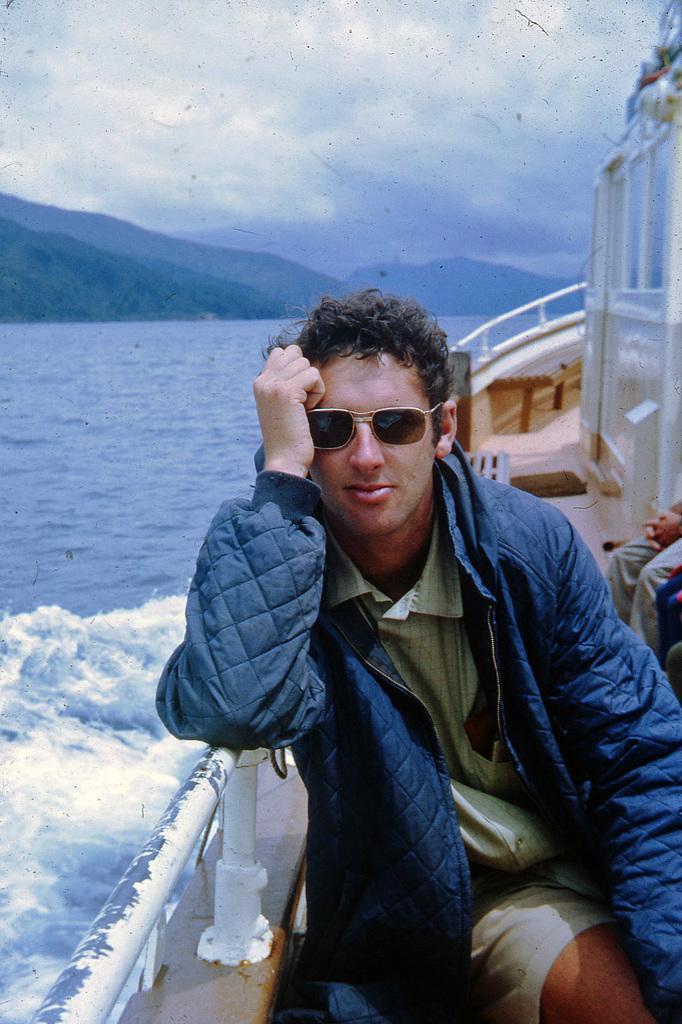Could you give a brief overview of what you see in this image? In this image a person wearing a blue jacket is sitting on the boat. Right side few persons are sitting in the boat. There are few benches in the boat. Beside there is water having tides. There are few hills. Top of image there is sky. 